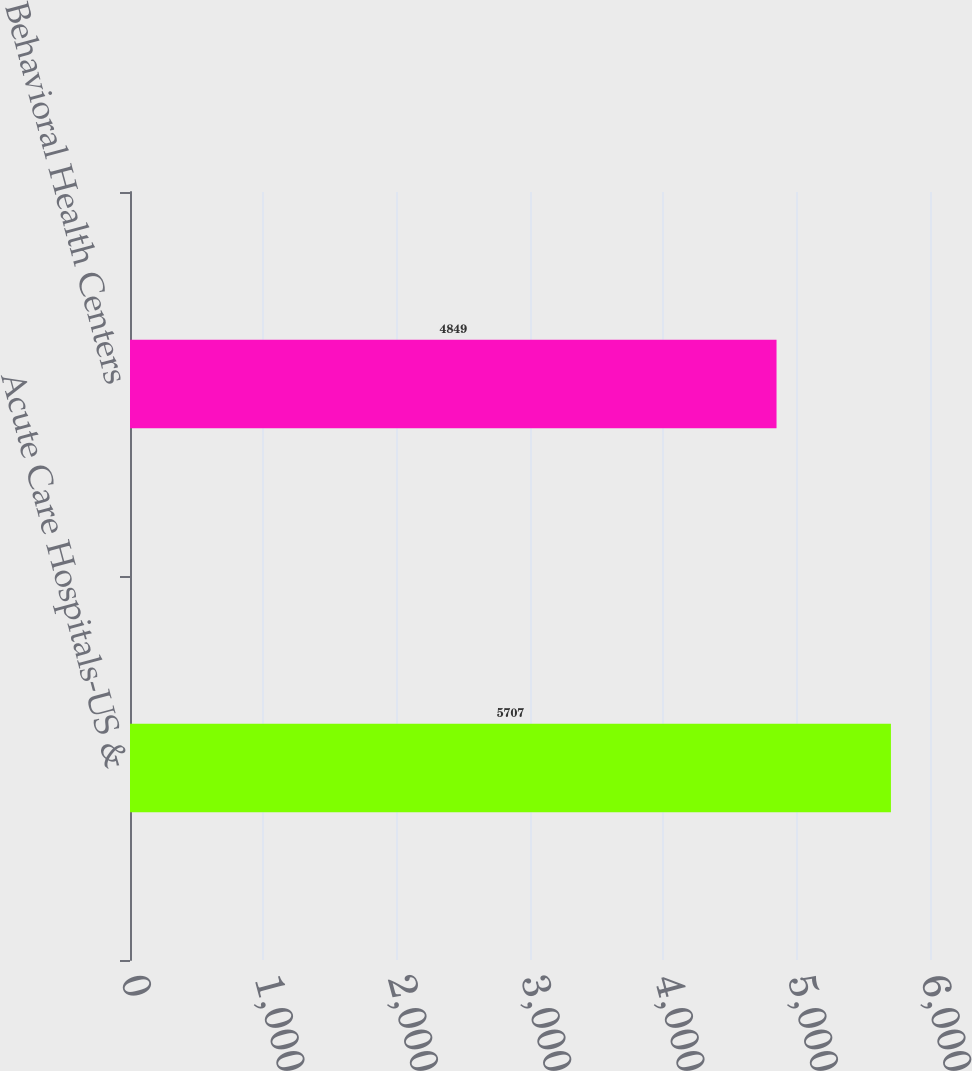<chart> <loc_0><loc_0><loc_500><loc_500><bar_chart><fcel>Acute Care Hospitals-US &<fcel>Behavioral Health Centers<nl><fcel>5707<fcel>4849<nl></chart> 